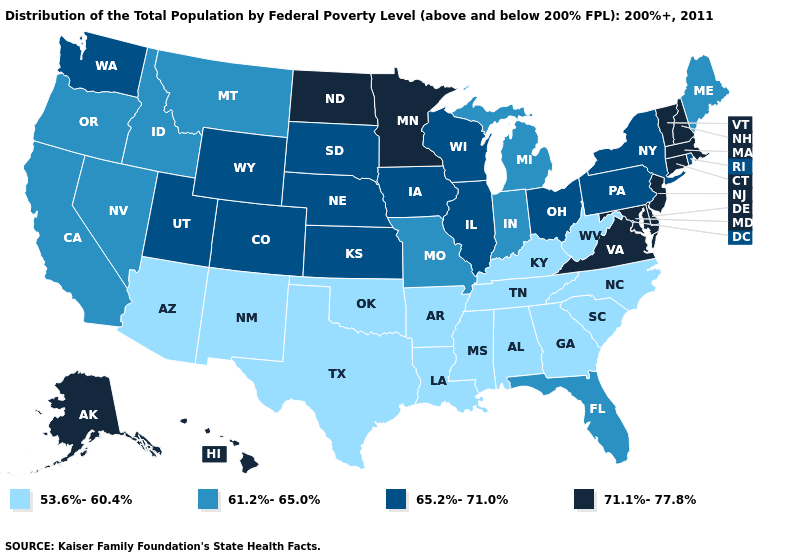Does New Jersey have the highest value in the Northeast?
Quick response, please. Yes. Among the states that border Oregon , does Washington have the lowest value?
Keep it brief. No. Among the states that border Florida , which have the lowest value?
Write a very short answer. Alabama, Georgia. How many symbols are there in the legend?
Answer briefly. 4. What is the value of Delaware?
Give a very brief answer. 71.1%-77.8%. Does Nebraska have the lowest value in the USA?
Give a very brief answer. No. What is the value of Wyoming?
Be succinct. 65.2%-71.0%. Does Mississippi have the same value as New York?
Keep it brief. No. Does Arkansas have a lower value than Minnesota?
Give a very brief answer. Yes. Name the states that have a value in the range 53.6%-60.4%?
Quick response, please. Alabama, Arizona, Arkansas, Georgia, Kentucky, Louisiana, Mississippi, New Mexico, North Carolina, Oklahoma, South Carolina, Tennessee, Texas, West Virginia. Among the states that border Rhode Island , which have the highest value?
Concise answer only. Connecticut, Massachusetts. Which states have the lowest value in the Northeast?
Give a very brief answer. Maine. Among the states that border Colorado , does Kansas have the highest value?
Be succinct. Yes. Which states hav the highest value in the Northeast?
Keep it brief. Connecticut, Massachusetts, New Hampshire, New Jersey, Vermont. What is the lowest value in the USA?
Short answer required. 53.6%-60.4%. 